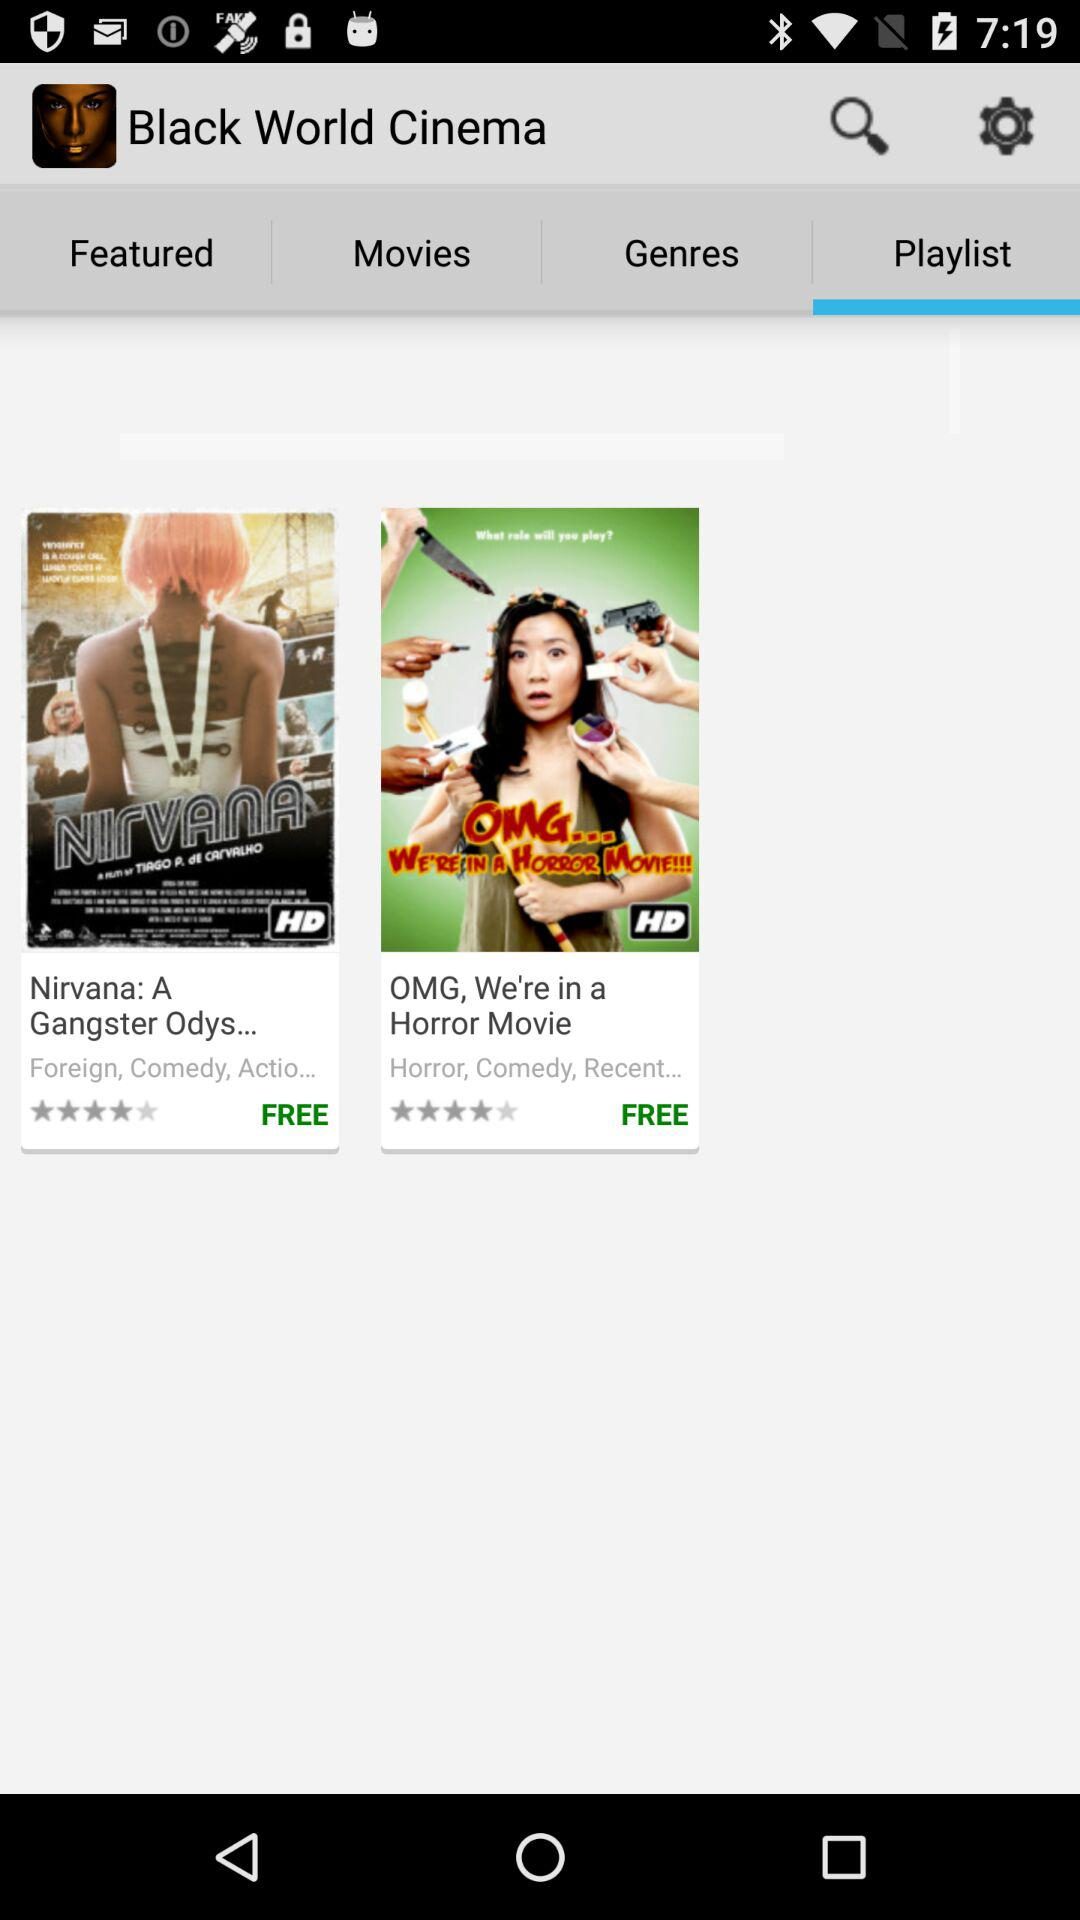What is the star rating of the movie "OMG, We're in a Horror Movie"? The rating is 4 stars. 